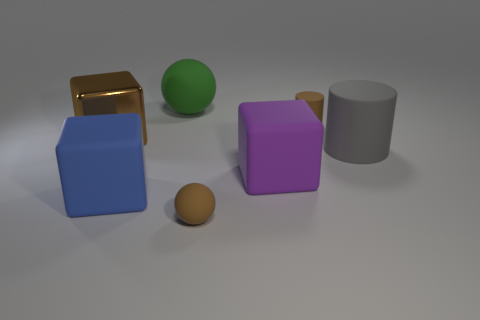Is there anything else that is the same material as the brown block?
Give a very brief answer. No. Is there any other thing that has the same color as the big matte sphere?
Provide a short and direct response. No. How many big brown blocks are on the left side of the sphere that is in front of the big green rubber ball?
Provide a succinct answer. 1. There is a matte sphere that is the same size as the metal thing; what is its color?
Provide a short and direct response. Green. What is the tiny brown object right of the big purple rubber thing made of?
Offer a terse response. Rubber. The thing that is both on the left side of the large gray matte cylinder and right of the big purple block is made of what material?
Offer a terse response. Rubber. Do the brown sphere in front of the brown cube and the brown matte cylinder have the same size?
Your answer should be compact. Yes. There is a gray matte thing; what shape is it?
Your response must be concise. Cylinder. How many small brown metal objects have the same shape as the blue thing?
Ensure brevity in your answer.  0. What number of rubber objects are both behind the purple matte object and to the right of the green thing?
Your answer should be compact. 2. 